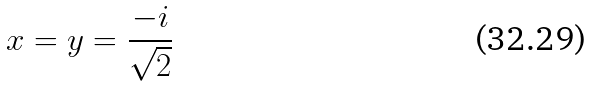<formula> <loc_0><loc_0><loc_500><loc_500>x = y = \frac { - i } { \sqrt { 2 } }</formula> 